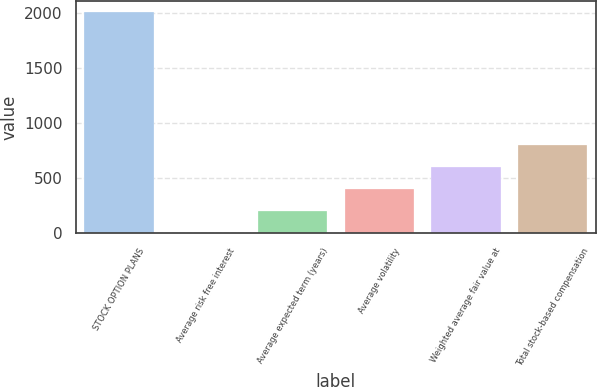<chart> <loc_0><loc_0><loc_500><loc_500><bar_chart><fcel>STOCK OPTION PLANS<fcel>Average risk free interest<fcel>Average expected term (years)<fcel>Average volatility<fcel>Weighted average fair value at<fcel>Total stock-based compensation<nl><fcel>2011<fcel>2.16<fcel>203.04<fcel>403.92<fcel>604.8<fcel>805.68<nl></chart> 